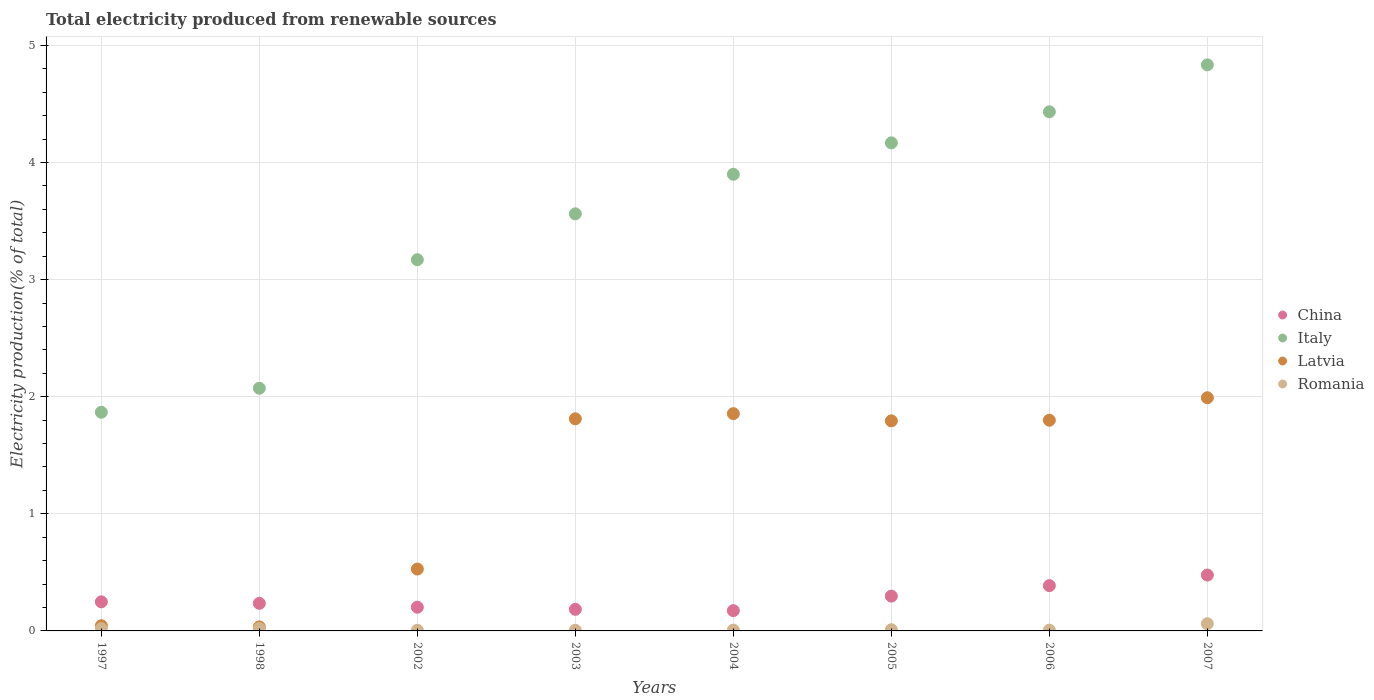What is the total electricity produced in Romania in 1998?
Your answer should be very brief. 0.02. Across all years, what is the maximum total electricity produced in Romania?
Keep it short and to the point. 0.06. Across all years, what is the minimum total electricity produced in Latvia?
Offer a very short reply. 0.03. What is the total total electricity produced in Italy in the graph?
Offer a very short reply. 28. What is the difference between the total electricity produced in Romania in 2002 and that in 2006?
Give a very brief answer. -0. What is the difference between the total electricity produced in China in 2006 and the total electricity produced in Romania in 2003?
Offer a very short reply. 0.38. What is the average total electricity produced in Romania per year?
Ensure brevity in your answer.  0.02. In the year 2003, what is the difference between the total electricity produced in Latvia and total electricity produced in China?
Make the answer very short. 1.63. In how many years, is the total electricity produced in Romania greater than 2.6 %?
Provide a short and direct response. 0. What is the ratio of the total electricity produced in Italy in 2005 to that in 2006?
Offer a terse response. 0.94. Is the total electricity produced in China in 1998 less than that in 2006?
Offer a very short reply. Yes. Is the difference between the total electricity produced in Latvia in 1997 and 2005 greater than the difference between the total electricity produced in China in 1997 and 2005?
Give a very brief answer. No. What is the difference between the highest and the second highest total electricity produced in Italy?
Provide a succinct answer. 0.4. What is the difference between the highest and the lowest total electricity produced in Latvia?
Offer a very short reply. 1.96. Is it the case that in every year, the sum of the total electricity produced in Romania and total electricity produced in Italy  is greater than the sum of total electricity produced in Latvia and total electricity produced in China?
Offer a terse response. Yes. Is it the case that in every year, the sum of the total electricity produced in China and total electricity produced in Italy  is greater than the total electricity produced in Romania?
Offer a terse response. Yes. Is the total electricity produced in Latvia strictly greater than the total electricity produced in Italy over the years?
Your answer should be very brief. No. How many dotlines are there?
Your answer should be compact. 4. How many years are there in the graph?
Keep it short and to the point. 8. What is the difference between two consecutive major ticks on the Y-axis?
Offer a terse response. 1. Where does the legend appear in the graph?
Offer a terse response. Center right. How are the legend labels stacked?
Offer a very short reply. Vertical. What is the title of the graph?
Offer a very short reply. Total electricity produced from renewable sources. What is the label or title of the X-axis?
Provide a short and direct response. Years. What is the label or title of the Y-axis?
Give a very brief answer. Electricity production(% of total). What is the Electricity production(% of total) in China in 1997?
Your answer should be compact. 0.25. What is the Electricity production(% of total) in Italy in 1997?
Your response must be concise. 1.87. What is the Electricity production(% of total) in Latvia in 1997?
Provide a succinct answer. 0.04. What is the Electricity production(% of total) in Romania in 1997?
Ensure brevity in your answer.  0.02. What is the Electricity production(% of total) in China in 1998?
Ensure brevity in your answer.  0.24. What is the Electricity production(% of total) of Italy in 1998?
Your response must be concise. 2.07. What is the Electricity production(% of total) in Latvia in 1998?
Your response must be concise. 0.03. What is the Electricity production(% of total) of Romania in 1998?
Make the answer very short. 0.02. What is the Electricity production(% of total) in China in 2002?
Provide a short and direct response. 0.2. What is the Electricity production(% of total) in Italy in 2002?
Your response must be concise. 3.17. What is the Electricity production(% of total) of Latvia in 2002?
Offer a terse response. 0.53. What is the Electricity production(% of total) in Romania in 2002?
Ensure brevity in your answer.  0.01. What is the Electricity production(% of total) of China in 2003?
Offer a very short reply. 0.18. What is the Electricity production(% of total) in Italy in 2003?
Your answer should be compact. 3.56. What is the Electricity production(% of total) of Latvia in 2003?
Make the answer very short. 1.81. What is the Electricity production(% of total) of Romania in 2003?
Ensure brevity in your answer.  0.01. What is the Electricity production(% of total) of China in 2004?
Provide a short and direct response. 0.17. What is the Electricity production(% of total) in Italy in 2004?
Provide a short and direct response. 3.9. What is the Electricity production(% of total) in Latvia in 2004?
Your answer should be compact. 1.86. What is the Electricity production(% of total) of Romania in 2004?
Give a very brief answer. 0.01. What is the Electricity production(% of total) of China in 2005?
Make the answer very short. 0.3. What is the Electricity production(% of total) in Italy in 2005?
Provide a succinct answer. 4.17. What is the Electricity production(% of total) in Latvia in 2005?
Your response must be concise. 1.79. What is the Electricity production(% of total) in Romania in 2005?
Offer a very short reply. 0.01. What is the Electricity production(% of total) in China in 2006?
Your answer should be compact. 0.39. What is the Electricity production(% of total) of Italy in 2006?
Ensure brevity in your answer.  4.43. What is the Electricity production(% of total) of Latvia in 2006?
Your answer should be very brief. 1.8. What is the Electricity production(% of total) of Romania in 2006?
Offer a very short reply. 0.01. What is the Electricity production(% of total) in China in 2007?
Your answer should be very brief. 0.48. What is the Electricity production(% of total) of Italy in 2007?
Offer a terse response. 4.83. What is the Electricity production(% of total) in Latvia in 2007?
Your answer should be very brief. 1.99. What is the Electricity production(% of total) in Romania in 2007?
Provide a short and direct response. 0.06. Across all years, what is the maximum Electricity production(% of total) of China?
Provide a succinct answer. 0.48. Across all years, what is the maximum Electricity production(% of total) in Italy?
Ensure brevity in your answer.  4.83. Across all years, what is the maximum Electricity production(% of total) in Latvia?
Provide a short and direct response. 1.99. Across all years, what is the maximum Electricity production(% of total) in Romania?
Make the answer very short. 0.06. Across all years, what is the minimum Electricity production(% of total) of China?
Offer a terse response. 0.17. Across all years, what is the minimum Electricity production(% of total) in Italy?
Give a very brief answer. 1.87. Across all years, what is the minimum Electricity production(% of total) of Latvia?
Ensure brevity in your answer.  0.03. Across all years, what is the minimum Electricity production(% of total) in Romania?
Make the answer very short. 0.01. What is the total Electricity production(% of total) of China in the graph?
Provide a short and direct response. 2.21. What is the total Electricity production(% of total) in Italy in the graph?
Your response must be concise. 28. What is the total Electricity production(% of total) of Latvia in the graph?
Ensure brevity in your answer.  9.86. What is the total Electricity production(% of total) of Romania in the graph?
Your answer should be very brief. 0.14. What is the difference between the Electricity production(% of total) of China in 1997 and that in 1998?
Provide a short and direct response. 0.01. What is the difference between the Electricity production(% of total) in Italy in 1997 and that in 1998?
Your answer should be compact. -0.2. What is the difference between the Electricity production(% of total) in Latvia in 1997 and that in 1998?
Ensure brevity in your answer.  0.01. What is the difference between the Electricity production(% of total) of Romania in 1997 and that in 1998?
Provide a succinct answer. -0. What is the difference between the Electricity production(% of total) in China in 1997 and that in 2002?
Your response must be concise. 0.05. What is the difference between the Electricity production(% of total) in Italy in 1997 and that in 2002?
Keep it short and to the point. -1.3. What is the difference between the Electricity production(% of total) of Latvia in 1997 and that in 2002?
Your answer should be compact. -0.48. What is the difference between the Electricity production(% of total) in Romania in 1997 and that in 2002?
Your answer should be compact. 0.01. What is the difference between the Electricity production(% of total) in China in 1997 and that in 2003?
Your answer should be compact. 0.06. What is the difference between the Electricity production(% of total) of Italy in 1997 and that in 2003?
Ensure brevity in your answer.  -1.69. What is the difference between the Electricity production(% of total) of Latvia in 1997 and that in 2003?
Your answer should be very brief. -1.77. What is the difference between the Electricity production(% of total) of Romania in 1997 and that in 2003?
Your answer should be compact. 0.01. What is the difference between the Electricity production(% of total) in China in 1997 and that in 2004?
Give a very brief answer. 0.08. What is the difference between the Electricity production(% of total) in Italy in 1997 and that in 2004?
Offer a terse response. -2.03. What is the difference between the Electricity production(% of total) in Latvia in 1997 and that in 2004?
Your response must be concise. -1.81. What is the difference between the Electricity production(% of total) in Romania in 1997 and that in 2004?
Provide a short and direct response. 0.01. What is the difference between the Electricity production(% of total) in China in 1997 and that in 2005?
Offer a very short reply. -0.05. What is the difference between the Electricity production(% of total) in Italy in 1997 and that in 2005?
Your answer should be compact. -2.3. What is the difference between the Electricity production(% of total) of Latvia in 1997 and that in 2005?
Offer a terse response. -1.75. What is the difference between the Electricity production(% of total) of Romania in 1997 and that in 2005?
Make the answer very short. 0.01. What is the difference between the Electricity production(% of total) of China in 1997 and that in 2006?
Ensure brevity in your answer.  -0.14. What is the difference between the Electricity production(% of total) in Italy in 1997 and that in 2006?
Keep it short and to the point. -2.57. What is the difference between the Electricity production(% of total) in Latvia in 1997 and that in 2006?
Provide a short and direct response. -1.75. What is the difference between the Electricity production(% of total) in Romania in 1997 and that in 2006?
Provide a short and direct response. 0.01. What is the difference between the Electricity production(% of total) in China in 1997 and that in 2007?
Provide a succinct answer. -0.23. What is the difference between the Electricity production(% of total) in Italy in 1997 and that in 2007?
Ensure brevity in your answer.  -2.97. What is the difference between the Electricity production(% of total) of Latvia in 1997 and that in 2007?
Offer a terse response. -1.95. What is the difference between the Electricity production(% of total) in Romania in 1997 and that in 2007?
Your answer should be very brief. -0.04. What is the difference between the Electricity production(% of total) of China in 1998 and that in 2002?
Your response must be concise. 0.03. What is the difference between the Electricity production(% of total) of Italy in 1998 and that in 2002?
Provide a short and direct response. -1.1. What is the difference between the Electricity production(% of total) of Latvia in 1998 and that in 2002?
Your response must be concise. -0.49. What is the difference between the Electricity production(% of total) of Romania in 1998 and that in 2002?
Make the answer very short. 0.02. What is the difference between the Electricity production(% of total) in China in 1998 and that in 2003?
Keep it short and to the point. 0.05. What is the difference between the Electricity production(% of total) in Italy in 1998 and that in 2003?
Your answer should be compact. -1.49. What is the difference between the Electricity production(% of total) in Latvia in 1998 and that in 2003?
Your answer should be compact. -1.78. What is the difference between the Electricity production(% of total) of Romania in 1998 and that in 2003?
Ensure brevity in your answer.  0.02. What is the difference between the Electricity production(% of total) of China in 1998 and that in 2004?
Ensure brevity in your answer.  0.06. What is the difference between the Electricity production(% of total) in Italy in 1998 and that in 2004?
Provide a succinct answer. -1.83. What is the difference between the Electricity production(% of total) of Latvia in 1998 and that in 2004?
Your answer should be compact. -1.82. What is the difference between the Electricity production(% of total) of Romania in 1998 and that in 2004?
Your answer should be very brief. 0.01. What is the difference between the Electricity production(% of total) of China in 1998 and that in 2005?
Offer a very short reply. -0.06. What is the difference between the Electricity production(% of total) of Italy in 1998 and that in 2005?
Your response must be concise. -2.1. What is the difference between the Electricity production(% of total) in Latvia in 1998 and that in 2005?
Offer a terse response. -1.76. What is the difference between the Electricity production(% of total) in Romania in 1998 and that in 2005?
Provide a succinct answer. 0.01. What is the difference between the Electricity production(% of total) of China in 1998 and that in 2006?
Offer a terse response. -0.15. What is the difference between the Electricity production(% of total) of Italy in 1998 and that in 2006?
Offer a terse response. -2.36. What is the difference between the Electricity production(% of total) of Latvia in 1998 and that in 2006?
Give a very brief answer. -1.76. What is the difference between the Electricity production(% of total) in Romania in 1998 and that in 2006?
Provide a succinct answer. 0.01. What is the difference between the Electricity production(% of total) of China in 1998 and that in 2007?
Offer a very short reply. -0.24. What is the difference between the Electricity production(% of total) of Italy in 1998 and that in 2007?
Your response must be concise. -2.76. What is the difference between the Electricity production(% of total) of Latvia in 1998 and that in 2007?
Provide a short and direct response. -1.96. What is the difference between the Electricity production(% of total) of Romania in 1998 and that in 2007?
Provide a short and direct response. -0.04. What is the difference between the Electricity production(% of total) of China in 2002 and that in 2003?
Your response must be concise. 0.02. What is the difference between the Electricity production(% of total) in Italy in 2002 and that in 2003?
Provide a succinct answer. -0.39. What is the difference between the Electricity production(% of total) in Latvia in 2002 and that in 2003?
Your answer should be very brief. -1.28. What is the difference between the Electricity production(% of total) of Romania in 2002 and that in 2003?
Ensure brevity in your answer.  0. What is the difference between the Electricity production(% of total) in China in 2002 and that in 2004?
Keep it short and to the point. 0.03. What is the difference between the Electricity production(% of total) of Italy in 2002 and that in 2004?
Your answer should be compact. -0.73. What is the difference between the Electricity production(% of total) in Latvia in 2002 and that in 2004?
Your answer should be very brief. -1.33. What is the difference between the Electricity production(% of total) in Romania in 2002 and that in 2004?
Make the answer very short. -0. What is the difference between the Electricity production(% of total) in China in 2002 and that in 2005?
Give a very brief answer. -0.09. What is the difference between the Electricity production(% of total) of Italy in 2002 and that in 2005?
Your response must be concise. -1. What is the difference between the Electricity production(% of total) of Latvia in 2002 and that in 2005?
Ensure brevity in your answer.  -1.27. What is the difference between the Electricity production(% of total) of Romania in 2002 and that in 2005?
Keep it short and to the point. -0. What is the difference between the Electricity production(% of total) in China in 2002 and that in 2006?
Provide a short and direct response. -0.18. What is the difference between the Electricity production(% of total) in Italy in 2002 and that in 2006?
Provide a succinct answer. -1.26. What is the difference between the Electricity production(% of total) in Latvia in 2002 and that in 2006?
Give a very brief answer. -1.27. What is the difference between the Electricity production(% of total) in Romania in 2002 and that in 2006?
Ensure brevity in your answer.  -0. What is the difference between the Electricity production(% of total) of China in 2002 and that in 2007?
Offer a terse response. -0.27. What is the difference between the Electricity production(% of total) of Italy in 2002 and that in 2007?
Offer a terse response. -1.66. What is the difference between the Electricity production(% of total) of Latvia in 2002 and that in 2007?
Your response must be concise. -1.46. What is the difference between the Electricity production(% of total) of Romania in 2002 and that in 2007?
Provide a short and direct response. -0.06. What is the difference between the Electricity production(% of total) in China in 2003 and that in 2004?
Your answer should be compact. 0.01. What is the difference between the Electricity production(% of total) of Italy in 2003 and that in 2004?
Ensure brevity in your answer.  -0.34. What is the difference between the Electricity production(% of total) of Latvia in 2003 and that in 2004?
Offer a terse response. -0.04. What is the difference between the Electricity production(% of total) of Romania in 2003 and that in 2004?
Your answer should be very brief. -0. What is the difference between the Electricity production(% of total) in China in 2003 and that in 2005?
Your response must be concise. -0.11. What is the difference between the Electricity production(% of total) of Italy in 2003 and that in 2005?
Offer a terse response. -0.61. What is the difference between the Electricity production(% of total) in Latvia in 2003 and that in 2005?
Give a very brief answer. 0.02. What is the difference between the Electricity production(% of total) in Romania in 2003 and that in 2005?
Your answer should be very brief. -0. What is the difference between the Electricity production(% of total) in China in 2003 and that in 2006?
Provide a succinct answer. -0.2. What is the difference between the Electricity production(% of total) of Italy in 2003 and that in 2006?
Offer a terse response. -0.87. What is the difference between the Electricity production(% of total) of Latvia in 2003 and that in 2006?
Provide a short and direct response. 0.01. What is the difference between the Electricity production(% of total) in Romania in 2003 and that in 2006?
Your answer should be very brief. -0. What is the difference between the Electricity production(% of total) of China in 2003 and that in 2007?
Your response must be concise. -0.29. What is the difference between the Electricity production(% of total) of Italy in 2003 and that in 2007?
Provide a succinct answer. -1.27. What is the difference between the Electricity production(% of total) of Latvia in 2003 and that in 2007?
Make the answer very short. -0.18. What is the difference between the Electricity production(% of total) in Romania in 2003 and that in 2007?
Provide a short and direct response. -0.06. What is the difference between the Electricity production(% of total) of China in 2004 and that in 2005?
Make the answer very short. -0.12. What is the difference between the Electricity production(% of total) in Italy in 2004 and that in 2005?
Your response must be concise. -0.27. What is the difference between the Electricity production(% of total) in Latvia in 2004 and that in 2005?
Your answer should be very brief. 0.06. What is the difference between the Electricity production(% of total) of Romania in 2004 and that in 2005?
Provide a succinct answer. -0. What is the difference between the Electricity production(% of total) of China in 2004 and that in 2006?
Keep it short and to the point. -0.21. What is the difference between the Electricity production(% of total) in Italy in 2004 and that in 2006?
Ensure brevity in your answer.  -0.53. What is the difference between the Electricity production(% of total) in Latvia in 2004 and that in 2006?
Offer a very short reply. 0.06. What is the difference between the Electricity production(% of total) in Romania in 2004 and that in 2006?
Your answer should be very brief. 0. What is the difference between the Electricity production(% of total) in China in 2004 and that in 2007?
Provide a short and direct response. -0.3. What is the difference between the Electricity production(% of total) in Italy in 2004 and that in 2007?
Offer a terse response. -0.93. What is the difference between the Electricity production(% of total) in Latvia in 2004 and that in 2007?
Your answer should be compact. -0.14. What is the difference between the Electricity production(% of total) in Romania in 2004 and that in 2007?
Offer a very short reply. -0.05. What is the difference between the Electricity production(% of total) of China in 2005 and that in 2006?
Offer a very short reply. -0.09. What is the difference between the Electricity production(% of total) in Italy in 2005 and that in 2006?
Your answer should be very brief. -0.27. What is the difference between the Electricity production(% of total) of Latvia in 2005 and that in 2006?
Your answer should be very brief. -0.01. What is the difference between the Electricity production(% of total) in Romania in 2005 and that in 2006?
Provide a short and direct response. 0. What is the difference between the Electricity production(% of total) of China in 2005 and that in 2007?
Offer a very short reply. -0.18. What is the difference between the Electricity production(% of total) of Italy in 2005 and that in 2007?
Provide a short and direct response. -0.67. What is the difference between the Electricity production(% of total) of Latvia in 2005 and that in 2007?
Ensure brevity in your answer.  -0.2. What is the difference between the Electricity production(% of total) of Romania in 2005 and that in 2007?
Ensure brevity in your answer.  -0.05. What is the difference between the Electricity production(% of total) in China in 2006 and that in 2007?
Your answer should be very brief. -0.09. What is the difference between the Electricity production(% of total) in Italy in 2006 and that in 2007?
Your answer should be very brief. -0.4. What is the difference between the Electricity production(% of total) in Latvia in 2006 and that in 2007?
Your answer should be very brief. -0.19. What is the difference between the Electricity production(% of total) of Romania in 2006 and that in 2007?
Provide a short and direct response. -0.06. What is the difference between the Electricity production(% of total) in China in 1997 and the Electricity production(% of total) in Italy in 1998?
Give a very brief answer. -1.82. What is the difference between the Electricity production(% of total) in China in 1997 and the Electricity production(% of total) in Latvia in 1998?
Your answer should be compact. 0.21. What is the difference between the Electricity production(% of total) of China in 1997 and the Electricity production(% of total) of Romania in 1998?
Your answer should be very brief. 0.23. What is the difference between the Electricity production(% of total) of Italy in 1997 and the Electricity production(% of total) of Latvia in 1998?
Offer a terse response. 1.83. What is the difference between the Electricity production(% of total) of Italy in 1997 and the Electricity production(% of total) of Romania in 1998?
Provide a short and direct response. 1.85. What is the difference between the Electricity production(% of total) of Latvia in 1997 and the Electricity production(% of total) of Romania in 1998?
Keep it short and to the point. 0.02. What is the difference between the Electricity production(% of total) in China in 1997 and the Electricity production(% of total) in Italy in 2002?
Your answer should be very brief. -2.92. What is the difference between the Electricity production(% of total) of China in 1997 and the Electricity production(% of total) of Latvia in 2002?
Your answer should be compact. -0.28. What is the difference between the Electricity production(% of total) in China in 1997 and the Electricity production(% of total) in Romania in 2002?
Offer a terse response. 0.24. What is the difference between the Electricity production(% of total) in Italy in 1997 and the Electricity production(% of total) in Latvia in 2002?
Provide a short and direct response. 1.34. What is the difference between the Electricity production(% of total) in Italy in 1997 and the Electricity production(% of total) in Romania in 2002?
Provide a succinct answer. 1.86. What is the difference between the Electricity production(% of total) of Latvia in 1997 and the Electricity production(% of total) of Romania in 2002?
Offer a terse response. 0.04. What is the difference between the Electricity production(% of total) of China in 1997 and the Electricity production(% of total) of Italy in 2003?
Provide a succinct answer. -3.31. What is the difference between the Electricity production(% of total) in China in 1997 and the Electricity production(% of total) in Latvia in 2003?
Your answer should be compact. -1.56. What is the difference between the Electricity production(% of total) in China in 1997 and the Electricity production(% of total) in Romania in 2003?
Offer a terse response. 0.24. What is the difference between the Electricity production(% of total) in Italy in 1997 and the Electricity production(% of total) in Latvia in 2003?
Give a very brief answer. 0.06. What is the difference between the Electricity production(% of total) of Italy in 1997 and the Electricity production(% of total) of Romania in 2003?
Offer a very short reply. 1.86. What is the difference between the Electricity production(% of total) of Latvia in 1997 and the Electricity production(% of total) of Romania in 2003?
Keep it short and to the point. 0.04. What is the difference between the Electricity production(% of total) of China in 1997 and the Electricity production(% of total) of Italy in 2004?
Your answer should be very brief. -3.65. What is the difference between the Electricity production(% of total) of China in 1997 and the Electricity production(% of total) of Latvia in 2004?
Offer a terse response. -1.61. What is the difference between the Electricity production(% of total) in China in 1997 and the Electricity production(% of total) in Romania in 2004?
Ensure brevity in your answer.  0.24. What is the difference between the Electricity production(% of total) in Italy in 1997 and the Electricity production(% of total) in Latvia in 2004?
Give a very brief answer. 0.01. What is the difference between the Electricity production(% of total) in Italy in 1997 and the Electricity production(% of total) in Romania in 2004?
Ensure brevity in your answer.  1.86. What is the difference between the Electricity production(% of total) of Latvia in 1997 and the Electricity production(% of total) of Romania in 2004?
Offer a terse response. 0.04. What is the difference between the Electricity production(% of total) in China in 1997 and the Electricity production(% of total) in Italy in 2005?
Offer a very short reply. -3.92. What is the difference between the Electricity production(% of total) of China in 1997 and the Electricity production(% of total) of Latvia in 2005?
Offer a very short reply. -1.55. What is the difference between the Electricity production(% of total) in China in 1997 and the Electricity production(% of total) in Romania in 2005?
Ensure brevity in your answer.  0.24. What is the difference between the Electricity production(% of total) in Italy in 1997 and the Electricity production(% of total) in Latvia in 2005?
Your response must be concise. 0.07. What is the difference between the Electricity production(% of total) of Italy in 1997 and the Electricity production(% of total) of Romania in 2005?
Provide a succinct answer. 1.86. What is the difference between the Electricity production(% of total) of Latvia in 1997 and the Electricity production(% of total) of Romania in 2005?
Give a very brief answer. 0.03. What is the difference between the Electricity production(% of total) of China in 1997 and the Electricity production(% of total) of Italy in 2006?
Your response must be concise. -4.18. What is the difference between the Electricity production(% of total) in China in 1997 and the Electricity production(% of total) in Latvia in 2006?
Provide a succinct answer. -1.55. What is the difference between the Electricity production(% of total) of China in 1997 and the Electricity production(% of total) of Romania in 2006?
Your response must be concise. 0.24. What is the difference between the Electricity production(% of total) in Italy in 1997 and the Electricity production(% of total) in Latvia in 2006?
Ensure brevity in your answer.  0.07. What is the difference between the Electricity production(% of total) in Italy in 1997 and the Electricity production(% of total) in Romania in 2006?
Provide a short and direct response. 1.86. What is the difference between the Electricity production(% of total) of Latvia in 1997 and the Electricity production(% of total) of Romania in 2006?
Offer a very short reply. 0.04. What is the difference between the Electricity production(% of total) in China in 1997 and the Electricity production(% of total) in Italy in 2007?
Ensure brevity in your answer.  -4.59. What is the difference between the Electricity production(% of total) of China in 1997 and the Electricity production(% of total) of Latvia in 2007?
Keep it short and to the point. -1.74. What is the difference between the Electricity production(% of total) of China in 1997 and the Electricity production(% of total) of Romania in 2007?
Your answer should be compact. 0.19. What is the difference between the Electricity production(% of total) in Italy in 1997 and the Electricity production(% of total) in Latvia in 2007?
Your answer should be very brief. -0.12. What is the difference between the Electricity production(% of total) in Italy in 1997 and the Electricity production(% of total) in Romania in 2007?
Give a very brief answer. 1.81. What is the difference between the Electricity production(% of total) in Latvia in 1997 and the Electricity production(% of total) in Romania in 2007?
Make the answer very short. -0.02. What is the difference between the Electricity production(% of total) of China in 1998 and the Electricity production(% of total) of Italy in 2002?
Provide a succinct answer. -2.93. What is the difference between the Electricity production(% of total) of China in 1998 and the Electricity production(% of total) of Latvia in 2002?
Make the answer very short. -0.29. What is the difference between the Electricity production(% of total) of China in 1998 and the Electricity production(% of total) of Romania in 2002?
Your answer should be compact. 0.23. What is the difference between the Electricity production(% of total) in Italy in 1998 and the Electricity production(% of total) in Latvia in 2002?
Offer a very short reply. 1.54. What is the difference between the Electricity production(% of total) of Italy in 1998 and the Electricity production(% of total) of Romania in 2002?
Give a very brief answer. 2.07. What is the difference between the Electricity production(% of total) of Latvia in 1998 and the Electricity production(% of total) of Romania in 2002?
Keep it short and to the point. 0.03. What is the difference between the Electricity production(% of total) of China in 1998 and the Electricity production(% of total) of Italy in 2003?
Your answer should be compact. -3.33. What is the difference between the Electricity production(% of total) of China in 1998 and the Electricity production(% of total) of Latvia in 2003?
Make the answer very short. -1.58. What is the difference between the Electricity production(% of total) in China in 1998 and the Electricity production(% of total) in Romania in 2003?
Offer a very short reply. 0.23. What is the difference between the Electricity production(% of total) of Italy in 1998 and the Electricity production(% of total) of Latvia in 2003?
Offer a very short reply. 0.26. What is the difference between the Electricity production(% of total) in Italy in 1998 and the Electricity production(% of total) in Romania in 2003?
Provide a succinct answer. 2.07. What is the difference between the Electricity production(% of total) of Latvia in 1998 and the Electricity production(% of total) of Romania in 2003?
Your answer should be compact. 0.03. What is the difference between the Electricity production(% of total) in China in 1998 and the Electricity production(% of total) in Italy in 2004?
Offer a very short reply. -3.66. What is the difference between the Electricity production(% of total) in China in 1998 and the Electricity production(% of total) in Latvia in 2004?
Your answer should be compact. -1.62. What is the difference between the Electricity production(% of total) in China in 1998 and the Electricity production(% of total) in Romania in 2004?
Provide a short and direct response. 0.23. What is the difference between the Electricity production(% of total) in Italy in 1998 and the Electricity production(% of total) in Latvia in 2004?
Make the answer very short. 0.22. What is the difference between the Electricity production(% of total) of Italy in 1998 and the Electricity production(% of total) of Romania in 2004?
Your answer should be very brief. 2.06. What is the difference between the Electricity production(% of total) of Latvia in 1998 and the Electricity production(% of total) of Romania in 2004?
Make the answer very short. 0.03. What is the difference between the Electricity production(% of total) in China in 1998 and the Electricity production(% of total) in Italy in 2005?
Ensure brevity in your answer.  -3.93. What is the difference between the Electricity production(% of total) of China in 1998 and the Electricity production(% of total) of Latvia in 2005?
Offer a very short reply. -1.56. What is the difference between the Electricity production(% of total) in China in 1998 and the Electricity production(% of total) in Romania in 2005?
Your answer should be compact. 0.23. What is the difference between the Electricity production(% of total) of Italy in 1998 and the Electricity production(% of total) of Latvia in 2005?
Your response must be concise. 0.28. What is the difference between the Electricity production(% of total) in Italy in 1998 and the Electricity production(% of total) in Romania in 2005?
Ensure brevity in your answer.  2.06. What is the difference between the Electricity production(% of total) in Latvia in 1998 and the Electricity production(% of total) in Romania in 2005?
Your response must be concise. 0.02. What is the difference between the Electricity production(% of total) in China in 1998 and the Electricity production(% of total) in Italy in 2006?
Your answer should be very brief. -4.2. What is the difference between the Electricity production(% of total) in China in 1998 and the Electricity production(% of total) in Latvia in 2006?
Your answer should be very brief. -1.56. What is the difference between the Electricity production(% of total) in China in 1998 and the Electricity production(% of total) in Romania in 2006?
Keep it short and to the point. 0.23. What is the difference between the Electricity production(% of total) of Italy in 1998 and the Electricity production(% of total) of Latvia in 2006?
Ensure brevity in your answer.  0.27. What is the difference between the Electricity production(% of total) of Italy in 1998 and the Electricity production(% of total) of Romania in 2006?
Ensure brevity in your answer.  2.07. What is the difference between the Electricity production(% of total) of Latvia in 1998 and the Electricity production(% of total) of Romania in 2006?
Offer a very short reply. 0.03. What is the difference between the Electricity production(% of total) of China in 1998 and the Electricity production(% of total) of Italy in 2007?
Make the answer very short. -4.6. What is the difference between the Electricity production(% of total) of China in 1998 and the Electricity production(% of total) of Latvia in 2007?
Provide a succinct answer. -1.76. What is the difference between the Electricity production(% of total) of China in 1998 and the Electricity production(% of total) of Romania in 2007?
Your response must be concise. 0.17. What is the difference between the Electricity production(% of total) in Italy in 1998 and the Electricity production(% of total) in Latvia in 2007?
Provide a succinct answer. 0.08. What is the difference between the Electricity production(% of total) of Italy in 1998 and the Electricity production(% of total) of Romania in 2007?
Your answer should be compact. 2.01. What is the difference between the Electricity production(% of total) in Latvia in 1998 and the Electricity production(% of total) in Romania in 2007?
Offer a terse response. -0.03. What is the difference between the Electricity production(% of total) of China in 2002 and the Electricity production(% of total) of Italy in 2003?
Ensure brevity in your answer.  -3.36. What is the difference between the Electricity production(% of total) of China in 2002 and the Electricity production(% of total) of Latvia in 2003?
Provide a short and direct response. -1.61. What is the difference between the Electricity production(% of total) of China in 2002 and the Electricity production(% of total) of Romania in 2003?
Give a very brief answer. 0.2. What is the difference between the Electricity production(% of total) of Italy in 2002 and the Electricity production(% of total) of Latvia in 2003?
Give a very brief answer. 1.36. What is the difference between the Electricity production(% of total) in Italy in 2002 and the Electricity production(% of total) in Romania in 2003?
Your response must be concise. 3.16. What is the difference between the Electricity production(% of total) in Latvia in 2002 and the Electricity production(% of total) in Romania in 2003?
Ensure brevity in your answer.  0.52. What is the difference between the Electricity production(% of total) of China in 2002 and the Electricity production(% of total) of Italy in 2004?
Your answer should be compact. -3.7. What is the difference between the Electricity production(% of total) of China in 2002 and the Electricity production(% of total) of Latvia in 2004?
Provide a succinct answer. -1.65. What is the difference between the Electricity production(% of total) in China in 2002 and the Electricity production(% of total) in Romania in 2004?
Give a very brief answer. 0.2. What is the difference between the Electricity production(% of total) in Italy in 2002 and the Electricity production(% of total) in Latvia in 2004?
Keep it short and to the point. 1.31. What is the difference between the Electricity production(% of total) in Italy in 2002 and the Electricity production(% of total) in Romania in 2004?
Provide a short and direct response. 3.16. What is the difference between the Electricity production(% of total) in Latvia in 2002 and the Electricity production(% of total) in Romania in 2004?
Offer a very short reply. 0.52. What is the difference between the Electricity production(% of total) of China in 2002 and the Electricity production(% of total) of Italy in 2005?
Provide a succinct answer. -3.97. What is the difference between the Electricity production(% of total) of China in 2002 and the Electricity production(% of total) of Latvia in 2005?
Your answer should be very brief. -1.59. What is the difference between the Electricity production(% of total) of China in 2002 and the Electricity production(% of total) of Romania in 2005?
Your answer should be compact. 0.19. What is the difference between the Electricity production(% of total) in Italy in 2002 and the Electricity production(% of total) in Latvia in 2005?
Provide a succinct answer. 1.38. What is the difference between the Electricity production(% of total) in Italy in 2002 and the Electricity production(% of total) in Romania in 2005?
Offer a terse response. 3.16. What is the difference between the Electricity production(% of total) in Latvia in 2002 and the Electricity production(% of total) in Romania in 2005?
Ensure brevity in your answer.  0.52. What is the difference between the Electricity production(% of total) of China in 2002 and the Electricity production(% of total) of Italy in 2006?
Offer a terse response. -4.23. What is the difference between the Electricity production(% of total) in China in 2002 and the Electricity production(% of total) in Latvia in 2006?
Ensure brevity in your answer.  -1.6. What is the difference between the Electricity production(% of total) of China in 2002 and the Electricity production(% of total) of Romania in 2006?
Offer a terse response. 0.2. What is the difference between the Electricity production(% of total) of Italy in 2002 and the Electricity production(% of total) of Latvia in 2006?
Provide a succinct answer. 1.37. What is the difference between the Electricity production(% of total) in Italy in 2002 and the Electricity production(% of total) in Romania in 2006?
Your answer should be very brief. 3.16. What is the difference between the Electricity production(% of total) in Latvia in 2002 and the Electricity production(% of total) in Romania in 2006?
Give a very brief answer. 0.52. What is the difference between the Electricity production(% of total) of China in 2002 and the Electricity production(% of total) of Italy in 2007?
Offer a very short reply. -4.63. What is the difference between the Electricity production(% of total) in China in 2002 and the Electricity production(% of total) in Latvia in 2007?
Make the answer very short. -1.79. What is the difference between the Electricity production(% of total) of China in 2002 and the Electricity production(% of total) of Romania in 2007?
Offer a terse response. 0.14. What is the difference between the Electricity production(% of total) of Italy in 2002 and the Electricity production(% of total) of Latvia in 2007?
Make the answer very short. 1.18. What is the difference between the Electricity production(% of total) of Italy in 2002 and the Electricity production(% of total) of Romania in 2007?
Make the answer very short. 3.11. What is the difference between the Electricity production(% of total) in Latvia in 2002 and the Electricity production(% of total) in Romania in 2007?
Ensure brevity in your answer.  0.47. What is the difference between the Electricity production(% of total) of China in 2003 and the Electricity production(% of total) of Italy in 2004?
Ensure brevity in your answer.  -3.71. What is the difference between the Electricity production(% of total) of China in 2003 and the Electricity production(% of total) of Latvia in 2004?
Make the answer very short. -1.67. What is the difference between the Electricity production(% of total) in China in 2003 and the Electricity production(% of total) in Romania in 2004?
Your answer should be very brief. 0.18. What is the difference between the Electricity production(% of total) of Italy in 2003 and the Electricity production(% of total) of Latvia in 2004?
Provide a succinct answer. 1.71. What is the difference between the Electricity production(% of total) in Italy in 2003 and the Electricity production(% of total) in Romania in 2004?
Provide a succinct answer. 3.55. What is the difference between the Electricity production(% of total) of Latvia in 2003 and the Electricity production(% of total) of Romania in 2004?
Provide a short and direct response. 1.8. What is the difference between the Electricity production(% of total) in China in 2003 and the Electricity production(% of total) in Italy in 2005?
Keep it short and to the point. -3.98. What is the difference between the Electricity production(% of total) in China in 2003 and the Electricity production(% of total) in Latvia in 2005?
Your answer should be very brief. -1.61. What is the difference between the Electricity production(% of total) of China in 2003 and the Electricity production(% of total) of Romania in 2005?
Your answer should be very brief. 0.17. What is the difference between the Electricity production(% of total) of Italy in 2003 and the Electricity production(% of total) of Latvia in 2005?
Your answer should be very brief. 1.77. What is the difference between the Electricity production(% of total) in Italy in 2003 and the Electricity production(% of total) in Romania in 2005?
Offer a very short reply. 3.55. What is the difference between the Electricity production(% of total) in Latvia in 2003 and the Electricity production(% of total) in Romania in 2005?
Offer a very short reply. 1.8. What is the difference between the Electricity production(% of total) of China in 2003 and the Electricity production(% of total) of Italy in 2006?
Ensure brevity in your answer.  -4.25. What is the difference between the Electricity production(% of total) of China in 2003 and the Electricity production(% of total) of Latvia in 2006?
Provide a short and direct response. -1.61. What is the difference between the Electricity production(% of total) of China in 2003 and the Electricity production(% of total) of Romania in 2006?
Provide a short and direct response. 0.18. What is the difference between the Electricity production(% of total) of Italy in 2003 and the Electricity production(% of total) of Latvia in 2006?
Give a very brief answer. 1.76. What is the difference between the Electricity production(% of total) in Italy in 2003 and the Electricity production(% of total) in Romania in 2006?
Make the answer very short. 3.56. What is the difference between the Electricity production(% of total) in Latvia in 2003 and the Electricity production(% of total) in Romania in 2006?
Your answer should be compact. 1.8. What is the difference between the Electricity production(% of total) of China in 2003 and the Electricity production(% of total) of Italy in 2007?
Ensure brevity in your answer.  -4.65. What is the difference between the Electricity production(% of total) in China in 2003 and the Electricity production(% of total) in Latvia in 2007?
Your answer should be compact. -1.81. What is the difference between the Electricity production(% of total) of China in 2003 and the Electricity production(% of total) of Romania in 2007?
Your answer should be compact. 0.12. What is the difference between the Electricity production(% of total) of Italy in 2003 and the Electricity production(% of total) of Latvia in 2007?
Make the answer very short. 1.57. What is the difference between the Electricity production(% of total) in Italy in 2003 and the Electricity production(% of total) in Romania in 2007?
Keep it short and to the point. 3.5. What is the difference between the Electricity production(% of total) of Latvia in 2003 and the Electricity production(% of total) of Romania in 2007?
Offer a very short reply. 1.75. What is the difference between the Electricity production(% of total) in China in 2004 and the Electricity production(% of total) in Italy in 2005?
Give a very brief answer. -3.99. What is the difference between the Electricity production(% of total) in China in 2004 and the Electricity production(% of total) in Latvia in 2005?
Provide a succinct answer. -1.62. What is the difference between the Electricity production(% of total) in China in 2004 and the Electricity production(% of total) in Romania in 2005?
Provide a succinct answer. 0.16. What is the difference between the Electricity production(% of total) of Italy in 2004 and the Electricity production(% of total) of Latvia in 2005?
Ensure brevity in your answer.  2.11. What is the difference between the Electricity production(% of total) in Italy in 2004 and the Electricity production(% of total) in Romania in 2005?
Provide a succinct answer. 3.89. What is the difference between the Electricity production(% of total) of Latvia in 2004 and the Electricity production(% of total) of Romania in 2005?
Offer a very short reply. 1.85. What is the difference between the Electricity production(% of total) in China in 2004 and the Electricity production(% of total) in Italy in 2006?
Your answer should be very brief. -4.26. What is the difference between the Electricity production(% of total) in China in 2004 and the Electricity production(% of total) in Latvia in 2006?
Give a very brief answer. -1.63. What is the difference between the Electricity production(% of total) of China in 2004 and the Electricity production(% of total) of Romania in 2006?
Provide a succinct answer. 0.17. What is the difference between the Electricity production(% of total) in Italy in 2004 and the Electricity production(% of total) in Romania in 2006?
Your answer should be very brief. 3.89. What is the difference between the Electricity production(% of total) in Latvia in 2004 and the Electricity production(% of total) in Romania in 2006?
Ensure brevity in your answer.  1.85. What is the difference between the Electricity production(% of total) in China in 2004 and the Electricity production(% of total) in Italy in 2007?
Offer a terse response. -4.66. What is the difference between the Electricity production(% of total) of China in 2004 and the Electricity production(% of total) of Latvia in 2007?
Make the answer very short. -1.82. What is the difference between the Electricity production(% of total) in China in 2004 and the Electricity production(% of total) in Romania in 2007?
Offer a terse response. 0.11. What is the difference between the Electricity production(% of total) in Italy in 2004 and the Electricity production(% of total) in Latvia in 2007?
Ensure brevity in your answer.  1.91. What is the difference between the Electricity production(% of total) in Italy in 2004 and the Electricity production(% of total) in Romania in 2007?
Keep it short and to the point. 3.84. What is the difference between the Electricity production(% of total) in Latvia in 2004 and the Electricity production(% of total) in Romania in 2007?
Your answer should be compact. 1.79. What is the difference between the Electricity production(% of total) of China in 2005 and the Electricity production(% of total) of Italy in 2006?
Keep it short and to the point. -4.14. What is the difference between the Electricity production(% of total) of China in 2005 and the Electricity production(% of total) of Latvia in 2006?
Ensure brevity in your answer.  -1.5. What is the difference between the Electricity production(% of total) in China in 2005 and the Electricity production(% of total) in Romania in 2006?
Make the answer very short. 0.29. What is the difference between the Electricity production(% of total) of Italy in 2005 and the Electricity production(% of total) of Latvia in 2006?
Your answer should be very brief. 2.37. What is the difference between the Electricity production(% of total) of Italy in 2005 and the Electricity production(% of total) of Romania in 2006?
Provide a short and direct response. 4.16. What is the difference between the Electricity production(% of total) of Latvia in 2005 and the Electricity production(% of total) of Romania in 2006?
Keep it short and to the point. 1.79. What is the difference between the Electricity production(% of total) of China in 2005 and the Electricity production(% of total) of Italy in 2007?
Offer a very short reply. -4.54. What is the difference between the Electricity production(% of total) of China in 2005 and the Electricity production(% of total) of Latvia in 2007?
Provide a succinct answer. -1.69. What is the difference between the Electricity production(% of total) in China in 2005 and the Electricity production(% of total) in Romania in 2007?
Offer a very short reply. 0.24. What is the difference between the Electricity production(% of total) of Italy in 2005 and the Electricity production(% of total) of Latvia in 2007?
Keep it short and to the point. 2.18. What is the difference between the Electricity production(% of total) of Italy in 2005 and the Electricity production(% of total) of Romania in 2007?
Ensure brevity in your answer.  4.11. What is the difference between the Electricity production(% of total) in Latvia in 2005 and the Electricity production(% of total) in Romania in 2007?
Give a very brief answer. 1.73. What is the difference between the Electricity production(% of total) of China in 2006 and the Electricity production(% of total) of Italy in 2007?
Give a very brief answer. -4.45. What is the difference between the Electricity production(% of total) of China in 2006 and the Electricity production(% of total) of Latvia in 2007?
Make the answer very short. -1.6. What is the difference between the Electricity production(% of total) in China in 2006 and the Electricity production(% of total) in Romania in 2007?
Your response must be concise. 0.33. What is the difference between the Electricity production(% of total) of Italy in 2006 and the Electricity production(% of total) of Latvia in 2007?
Ensure brevity in your answer.  2.44. What is the difference between the Electricity production(% of total) of Italy in 2006 and the Electricity production(% of total) of Romania in 2007?
Your response must be concise. 4.37. What is the difference between the Electricity production(% of total) in Latvia in 2006 and the Electricity production(% of total) in Romania in 2007?
Give a very brief answer. 1.74. What is the average Electricity production(% of total) of China per year?
Keep it short and to the point. 0.28. What is the average Electricity production(% of total) in Italy per year?
Your answer should be compact. 3.5. What is the average Electricity production(% of total) in Latvia per year?
Keep it short and to the point. 1.23. What is the average Electricity production(% of total) in Romania per year?
Give a very brief answer. 0.02. In the year 1997, what is the difference between the Electricity production(% of total) in China and Electricity production(% of total) in Italy?
Offer a terse response. -1.62. In the year 1997, what is the difference between the Electricity production(% of total) in China and Electricity production(% of total) in Latvia?
Provide a succinct answer. 0.2. In the year 1997, what is the difference between the Electricity production(% of total) in China and Electricity production(% of total) in Romania?
Offer a very short reply. 0.23. In the year 1997, what is the difference between the Electricity production(% of total) in Italy and Electricity production(% of total) in Latvia?
Give a very brief answer. 1.82. In the year 1997, what is the difference between the Electricity production(% of total) of Italy and Electricity production(% of total) of Romania?
Provide a short and direct response. 1.85. In the year 1997, what is the difference between the Electricity production(% of total) of Latvia and Electricity production(% of total) of Romania?
Your response must be concise. 0.03. In the year 1998, what is the difference between the Electricity production(% of total) of China and Electricity production(% of total) of Italy?
Give a very brief answer. -1.84. In the year 1998, what is the difference between the Electricity production(% of total) in China and Electricity production(% of total) in Latvia?
Provide a succinct answer. 0.2. In the year 1998, what is the difference between the Electricity production(% of total) in China and Electricity production(% of total) in Romania?
Provide a succinct answer. 0.21. In the year 1998, what is the difference between the Electricity production(% of total) of Italy and Electricity production(% of total) of Latvia?
Your answer should be very brief. 2.04. In the year 1998, what is the difference between the Electricity production(% of total) of Italy and Electricity production(% of total) of Romania?
Provide a short and direct response. 2.05. In the year 1998, what is the difference between the Electricity production(% of total) in Latvia and Electricity production(% of total) in Romania?
Offer a terse response. 0.01. In the year 2002, what is the difference between the Electricity production(% of total) in China and Electricity production(% of total) in Italy?
Your response must be concise. -2.97. In the year 2002, what is the difference between the Electricity production(% of total) in China and Electricity production(% of total) in Latvia?
Offer a terse response. -0.33. In the year 2002, what is the difference between the Electricity production(% of total) in China and Electricity production(% of total) in Romania?
Make the answer very short. 0.2. In the year 2002, what is the difference between the Electricity production(% of total) in Italy and Electricity production(% of total) in Latvia?
Provide a succinct answer. 2.64. In the year 2002, what is the difference between the Electricity production(% of total) in Italy and Electricity production(% of total) in Romania?
Keep it short and to the point. 3.16. In the year 2002, what is the difference between the Electricity production(% of total) of Latvia and Electricity production(% of total) of Romania?
Your answer should be compact. 0.52. In the year 2003, what is the difference between the Electricity production(% of total) in China and Electricity production(% of total) in Italy?
Your response must be concise. -3.38. In the year 2003, what is the difference between the Electricity production(% of total) of China and Electricity production(% of total) of Latvia?
Provide a succinct answer. -1.63. In the year 2003, what is the difference between the Electricity production(% of total) of China and Electricity production(% of total) of Romania?
Provide a succinct answer. 0.18. In the year 2003, what is the difference between the Electricity production(% of total) in Italy and Electricity production(% of total) in Latvia?
Offer a terse response. 1.75. In the year 2003, what is the difference between the Electricity production(% of total) in Italy and Electricity production(% of total) in Romania?
Ensure brevity in your answer.  3.56. In the year 2003, what is the difference between the Electricity production(% of total) in Latvia and Electricity production(% of total) in Romania?
Your response must be concise. 1.81. In the year 2004, what is the difference between the Electricity production(% of total) in China and Electricity production(% of total) in Italy?
Provide a succinct answer. -3.73. In the year 2004, what is the difference between the Electricity production(% of total) of China and Electricity production(% of total) of Latvia?
Keep it short and to the point. -1.68. In the year 2004, what is the difference between the Electricity production(% of total) in China and Electricity production(% of total) in Romania?
Your answer should be very brief. 0.17. In the year 2004, what is the difference between the Electricity production(% of total) in Italy and Electricity production(% of total) in Latvia?
Provide a succinct answer. 2.04. In the year 2004, what is the difference between the Electricity production(% of total) of Italy and Electricity production(% of total) of Romania?
Keep it short and to the point. 3.89. In the year 2004, what is the difference between the Electricity production(% of total) of Latvia and Electricity production(% of total) of Romania?
Offer a very short reply. 1.85. In the year 2005, what is the difference between the Electricity production(% of total) in China and Electricity production(% of total) in Italy?
Make the answer very short. -3.87. In the year 2005, what is the difference between the Electricity production(% of total) of China and Electricity production(% of total) of Latvia?
Provide a succinct answer. -1.5. In the year 2005, what is the difference between the Electricity production(% of total) in China and Electricity production(% of total) in Romania?
Your answer should be compact. 0.29. In the year 2005, what is the difference between the Electricity production(% of total) in Italy and Electricity production(% of total) in Latvia?
Give a very brief answer. 2.37. In the year 2005, what is the difference between the Electricity production(% of total) of Italy and Electricity production(% of total) of Romania?
Offer a terse response. 4.16. In the year 2005, what is the difference between the Electricity production(% of total) of Latvia and Electricity production(% of total) of Romania?
Provide a short and direct response. 1.78. In the year 2006, what is the difference between the Electricity production(% of total) of China and Electricity production(% of total) of Italy?
Your answer should be very brief. -4.05. In the year 2006, what is the difference between the Electricity production(% of total) of China and Electricity production(% of total) of Latvia?
Your response must be concise. -1.41. In the year 2006, what is the difference between the Electricity production(% of total) of China and Electricity production(% of total) of Romania?
Your answer should be compact. 0.38. In the year 2006, what is the difference between the Electricity production(% of total) of Italy and Electricity production(% of total) of Latvia?
Offer a very short reply. 2.63. In the year 2006, what is the difference between the Electricity production(% of total) of Italy and Electricity production(% of total) of Romania?
Offer a terse response. 4.43. In the year 2006, what is the difference between the Electricity production(% of total) in Latvia and Electricity production(% of total) in Romania?
Offer a very short reply. 1.79. In the year 2007, what is the difference between the Electricity production(% of total) in China and Electricity production(% of total) in Italy?
Provide a short and direct response. -4.36. In the year 2007, what is the difference between the Electricity production(% of total) of China and Electricity production(% of total) of Latvia?
Ensure brevity in your answer.  -1.51. In the year 2007, what is the difference between the Electricity production(% of total) of China and Electricity production(% of total) of Romania?
Offer a very short reply. 0.42. In the year 2007, what is the difference between the Electricity production(% of total) of Italy and Electricity production(% of total) of Latvia?
Your answer should be very brief. 2.84. In the year 2007, what is the difference between the Electricity production(% of total) in Italy and Electricity production(% of total) in Romania?
Your response must be concise. 4.77. In the year 2007, what is the difference between the Electricity production(% of total) in Latvia and Electricity production(% of total) in Romania?
Give a very brief answer. 1.93. What is the ratio of the Electricity production(% of total) of China in 1997 to that in 1998?
Provide a short and direct response. 1.06. What is the ratio of the Electricity production(% of total) of Italy in 1997 to that in 1998?
Provide a succinct answer. 0.9. What is the ratio of the Electricity production(% of total) of Latvia in 1997 to that in 1998?
Your response must be concise. 1.29. What is the ratio of the Electricity production(% of total) in Romania in 1997 to that in 1998?
Offer a very short reply. 0.94. What is the ratio of the Electricity production(% of total) in China in 1997 to that in 2002?
Your response must be concise. 1.23. What is the ratio of the Electricity production(% of total) in Italy in 1997 to that in 2002?
Give a very brief answer. 0.59. What is the ratio of the Electricity production(% of total) of Latvia in 1997 to that in 2002?
Make the answer very short. 0.08. What is the ratio of the Electricity production(% of total) in Romania in 1997 to that in 2002?
Provide a short and direct response. 3.51. What is the ratio of the Electricity production(% of total) in China in 1997 to that in 2003?
Give a very brief answer. 1.35. What is the ratio of the Electricity production(% of total) of Italy in 1997 to that in 2003?
Provide a succinct answer. 0.52. What is the ratio of the Electricity production(% of total) of Latvia in 1997 to that in 2003?
Your answer should be compact. 0.02. What is the ratio of the Electricity production(% of total) of Romania in 1997 to that in 2003?
Provide a succinct answer. 3.54. What is the ratio of the Electricity production(% of total) in China in 1997 to that in 2004?
Provide a succinct answer. 1.43. What is the ratio of the Electricity production(% of total) in Italy in 1997 to that in 2004?
Your answer should be compact. 0.48. What is the ratio of the Electricity production(% of total) in Latvia in 1997 to that in 2004?
Offer a very short reply. 0.02. What is the ratio of the Electricity production(% of total) in Romania in 1997 to that in 2004?
Your answer should be compact. 2.72. What is the ratio of the Electricity production(% of total) in China in 1997 to that in 2005?
Offer a terse response. 0.84. What is the ratio of the Electricity production(% of total) of Italy in 1997 to that in 2005?
Offer a very short reply. 0.45. What is the ratio of the Electricity production(% of total) in Latvia in 1997 to that in 2005?
Keep it short and to the point. 0.02. What is the ratio of the Electricity production(% of total) in Romania in 1997 to that in 2005?
Your response must be concise. 1.91. What is the ratio of the Electricity production(% of total) of China in 1997 to that in 2006?
Offer a very short reply. 0.64. What is the ratio of the Electricity production(% of total) in Italy in 1997 to that in 2006?
Provide a succinct answer. 0.42. What is the ratio of the Electricity production(% of total) of Latvia in 1997 to that in 2006?
Make the answer very short. 0.02. What is the ratio of the Electricity production(% of total) in Romania in 1997 to that in 2006?
Ensure brevity in your answer.  3.02. What is the ratio of the Electricity production(% of total) of China in 1997 to that in 2007?
Provide a short and direct response. 0.52. What is the ratio of the Electricity production(% of total) in Italy in 1997 to that in 2007?
Give a very brief answer. 0.39. What is the ratio of the Electricity production(% of total) of Latvia in 1997 to that in 2007?
Offer a terse response. 0.02. What is the ratio of the Electricity production(% of total) in Romania in 1997 to that in 2007?
Your response must be concise. 0.31. What is the ratio of the Electricity production(% of total) of China in 1998 to that in 2002?
Your answer should be very brief. 1.16. What is the ratio of the Electricity production(% of total) in Italy in 1998 to that in 2002?
Your answer should be very brief. 0.65. What is the ratio of the Electricity production(% of total) of Latvia in 1998 to that in 2002?
Give a very brief answer. 0.07. What is the ratio of the Electricity production(% of total) of Romania in 1998 to that in 2002?
Keep it short and to the point. 3.75. What is the ratio of the Electricity production(% of total) in China in 1998 to that in 2003?
Ensure brevity in your answer.  1.28. What is the ratio of the Electricity production(% of total) of Italy in 1998 to that in 2003?
Your response must be concise. 0.58. What is the ratio of the Electricity production(% of total) in Latvia in 1998 to that in 2003?
Provide a succinct answer. 0.02. What is the ratio of the Electricity production(% of total) in Romania in 1998 to that in 2003?
Offer a terse response. 3.78. What is the ratio of the Electricity production(% of total) of China in 1998 to that in 2004?
Provide a succinct answer. 1.36. What is the ratio of the Electricity production(% of total) in Italy in 1998 to that in 2004?
Make the answer very short. 0.53. What is the ratio of the Electricity production(% of total) in Latvia in 1998 to that in 2004?
Keep it short and to the point. 0.02. What is the ratio of the Electricity production(% of total) in Romania in 1998 to that in 2004?
Your answer should be very brief. 2.9. What is the ratio of the Electricity production(% of total) in China in 1998 to that in 2005?
Give a very brief answer. 0.79. What is the ratio of the Electricity production(% of total) of Italy in 1998 to that in 2005?
Ensure brevity in your answer.  0.5. What is the ratio of the Electricity production(% of total) of Latvia in 1998 to that in 2005?
Ensure brevity in your answer.  0.02. What is the ratio of the Electricity production(% of total) in Romania in 1998 to that in 2005?
Make the answer very short. 2.04. What is the ratio of the Electricity production(% of total) in China in 1998 to that in 2006?
Make the answer very short. 0.61. What is the ratio of the Electricity production(% of total) of Italy in 1998 to that in 2006?
Make the answer very short. 0.47. What is the ratio of the Electricity production(% of total) of Latvia in 1998 to that in 2006?
Offer a terse response. 0.02. What is the ratio of the Electricity production(% of total) of Romania in 1998 to that in 2006?
Offer a terse response. 3.22. What is the ratio of the Electricity production(% of total) of China in 1998 to that in 2007?
Give a very brief answer. 0.49. What is the ratio of the Electricity production(% of total) of Italy in 1998 to that in 2007?
Offer a very short reply. 0.43. What is the ratio of the Electricity production(% of total) in Latvia in 1998 to that in 2007?
Ensure brevity in your answer.  0.02. What is the ratio of the Electricity production(% of total) of Romania in 1998 to that in 2007?
Give a very brief answer. 0.33. What is the ratio of the Electricity production(% of total) of China in 2002 to that in 2003?
Provide a short and direct response. 1.1. What is the ratio of the Electricity production(% of total) in Italy in 2002 to that in 2003?
Make the answer very short. 0.89. What is the ratio of the Electricity production(% of total) of Latvia in 2002 to that in 2003?
Give a very brief answer. 0.29. What is the ratio of the Electricity production(% of total) of Romania in 2002 to that in 2003?
Ensure brevity in your answer.  1.01. What is the ratio of the Electricity production(% of total) of China in 2002 to that in 2004?
Provide a succinct answer. 1.17. What is the ratio of the Electricity production(% of total) in Italy in 2002 to that in 2004?
Your answer should be compact. 0.81. What is the ratio of the Electricity production(% of total) in Latvia in 2002 to that in 2004?
Provide a succinct answer. 0.28. What is the ratio of the Electricity production(% of total) of Romania in 2002 to that in 2004?
Keep it short and to the point. 0.77. What is the ratio of the Electricity production(% of total) in China in 2002 to that in 2005?
Provide a succinct answer. 0.68. What is the ratio of the Electricity production(% of total) in Italy in 2002 to that in 2005?
Your answer should be very brief. 0.76. What is the ratio of the Electricity production(% of total) of Latvia in 2002 to that in 2005?
Your answer should be compact. 0.29. What is the ratio of the Electricity production(% of total) in Romania in 2002 to that in 2005?
Ensure brevity in your answer.  0.54. What is the ratio of the Electricity production(% of total) of China in 2002 to that in 2006?
Offer a very short reply. 0.52. What is the ratio of the Electricity production(% of total) in Italy in 2002 to that in 2006?
Your response must be concise. 0.71. What is the ratio of the Electricity production(% of total) in Latvia in 2002 to that in 2006?
Keep it short and to the point. 0.29. What is the ratio of the Electricity production(% of total) of Romania in 2002 to that in 2006?
Your answer should be compact. 0.86. What is the ratio of the Electricity production(% of total) in China in 2002 to that in 2007?
Offer a very short reply. 0.42. What is the ratio of the Electricity production(% of total) in Italy in 2002 to that in 2007?
Provide a short and direct response. 0.66. What is the ratio of the Electricity production(% of total) of Latvia in 2002 to that in 2007?
Provide a succinct answer. 0.27. What is the ratio of the Electricity production(% of total) in Romania in 2002 to that in 2007?
Provide a succinct answer. 0.09. What is the ratio of the Electricity production(% of total) of China in 2003 to that in 2004?
Your response must be concise. 1.06. What is the ratio of the Electricity production(% of total) of Italy in 2003 to that in 2004?
Make the answer very short. 0.91. What is the ratio of the Electricity production(% of total) of Latvia in 2003 to that in 2004?
Your answer should be very brief. 0.98. What is the ratio of the Electricity production(% of total) of Romania in 2003 to that in 2004?
Offer a terse response. 0.77. What is the ratio of the Electricity production(% of total) in China in 2003 to that in 2005?
Your answer should be compact. 0.62. What is the ratio of the Electricity production(% of total) in Italy in 2003 to that in 2005?
Offer a terse response. 0.85. What is the ratio of the Electricity production(% of total) of Latvia in 2003 to that in 2005?
Provide a short and direct response. 1.01. What is the ratio of the Electricity production(% of total) in Romania in 2003 to that in 2005?
Give a very brief answer. 0.54. What is the ratio of the Electricity production(% of total) in China in 2003 to that in 2006?
Give a very brief answer. 0.48. What is the ratio of the Electricity production(% of total) in Italy in 2003 to that in 2006?
Keep it short and to the point. 0.8. What is the ratio of the Electricity production(% of total) of Latvia in 2003 to that in 2006?
Give a very brief answer. 1.01. What is the ratio of the Electricity production(% of total) in Romania in 2003 to that in 2006?
Keep it short and to the point. 0.85. What is the ratio of the Electricity production(% of total) of China in 2003 to that in 2007?
Make the answer very short. 0.39. What is the ratio of the Electricity production(% of total) in Italy in 2003 to that in 2007?
Give a very brief answer. 0.74. What is the ratio of the Electricity production(% of total) in Latvia in 2003 to that in 2007?
Keep it short and to the point. 0.91. What is the ratio of the Electricity production(% of total) in Romania in 2003 to that in 2007?
Your answer should be compact. 0.09. What is the ratio of the Electricity production(% of total) in China in 2004 to that in 2005?
Offer a terse response. 0.58. What is the ratio of the Electricity production(% of total) in Italy in 2004 to that in 2005?
Provide a succinct answer. 0.94. What is the ratio of the Electricity production(% of total) in Latvia in 2004 to that in 2005?
Your answer should be very brief. 1.03. What is the ratio of the Electricity production(% of total) of Romania in 2004 to that in 2005?
Your answer should be very brief. 0.7. What is the ratio of the Electricity production(% of total) of China in 2004 to that in 2006?
Give a very brief answer. 0.45. What is the ratio of the Electricity production(% of total) of Italy in 2004 to that in 2006?
Make the answer very short. 0.88. What is the ratio of the Electricity production(% of total) in Latvia in 2004 to that in 2006?
Provide a short and direct response. 1.03. What is the ratio of the Electricity production(% of total) in Romania in 2004 to that in 2006?
Ensure brevity in your answer.  1.11. What is the ratio of the Electricity production(% of total) of China in 2004 to that in 2007?
Your answer should be very brief. 0.36. What is the ratio of the Electricity production(% of total) of Italy in 2004 to that in 2007?
Your answer should be very brief. 0.81. What is the ratio of the Electricity production(% of total) in Latvia in 2004 to that in 2007?
Offer a terse response. 0.93. What is the ratio of the Electricity production(% of total) in Romania in 2004 to that in 2007?
Your response must be concise. 0.11. What is the ratio of the Electricity production(% of total) in China in 2005 to that in 2006?
Provide a short and direct response. 0.77. What is the ratio of the Electricity production(% of total) in Italy in 2005 to that in 2006?
Ensure brevity in your answer.  0.94. What is the ratio of the Electricity production(% of total) of Romania in 2005 to that in 2006?
Offer a terse response. 1.58. What is the ratio of the Electricity production(% of total) in China in 2005 to that in 2007?
Ensure brevity in your answer.  0.62. What is the ratio of the Electricity production(% of total) in Italy in 2005 to that in 2007?
Offer a terse response. 0.86. What is the ratio of the Electricity production(% of total) of Latvia in 2005 to that in 2007?
Your answer should be compact. 0.9. What is the ratio of the Electricity production(% of total) in Romania in 2005 to that in 2007?
Ensure brevity in your answer.  0.16. What is the ratio of the Electricity production(% of total) in China in 2006 to that in 2007?
Provide a short and direct response. 0.81. What is the ratio of the Electricity production(% of total) of Italy in 2006 to that in 2007?
Offer a very short reply. 0.92. What is the ratio of the Electricity production(% of total) of Latvia in 2006 to that in 2007?
Your response must be concise. 0.9. What is the ratio of the Electricity production(% of total) in Romania in 2006 to that in 2007?
Give a very brief answer. 0.1. What is the difference between the highest and the second highest Electricity production(% of total) in China?
Provide a succinct answer. 0.09. What is the difference between the highest and the second highest Electricity production(% of total) of Italy?
Provide a succinct answer. 0.4. What is the difference between the highest and the second highest Electricity production(% of total) of Latvia?
Keep it short and to the point. 0.14. What is the difference between the highest and the second highest Electricity production(% of total) of Romania?
Give a very brief answer. 0.04. What is the difference between the highest and the lowest Electricity production(% of total) of China?
Provide a succinct answer. 0.3. What is the difference between the highest and the lowest Electricity production(% of total) of Italy?
Your answer should be compact. 2.97. What is the difference between the highest and the lowest Electricity production(% of total) in Latvia?
Offer a terse response. 1.96. What is the difference between the highest and the lowest Electricity production(% of total) in Romania?
Give a very brief answer. 0.06. 